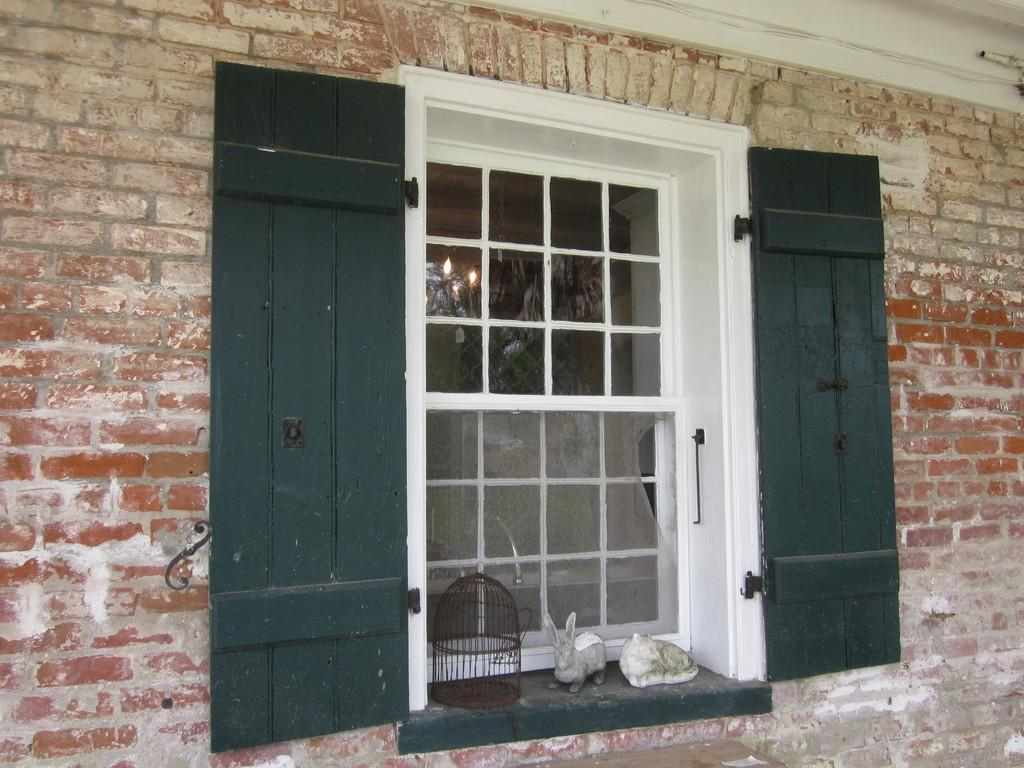What objects can be seen on the right side of the image? There are two toys on the right side of the image. Where is the cage located in the image? The cage is on a wall in the image. What is the cage's proximity to a window? The cage is near a window. What type of doors does the window have? The window has wooden doors. What is the window part of? The window is part of a building. What material is used for the building's wall? The building has a brick wall. What type of stem can be seen growing from the toys in the image? There are no stems growing from the toys in the image. How does the cage crush the zinc in the image? There is no zinc or crushing action depicted in the image. 